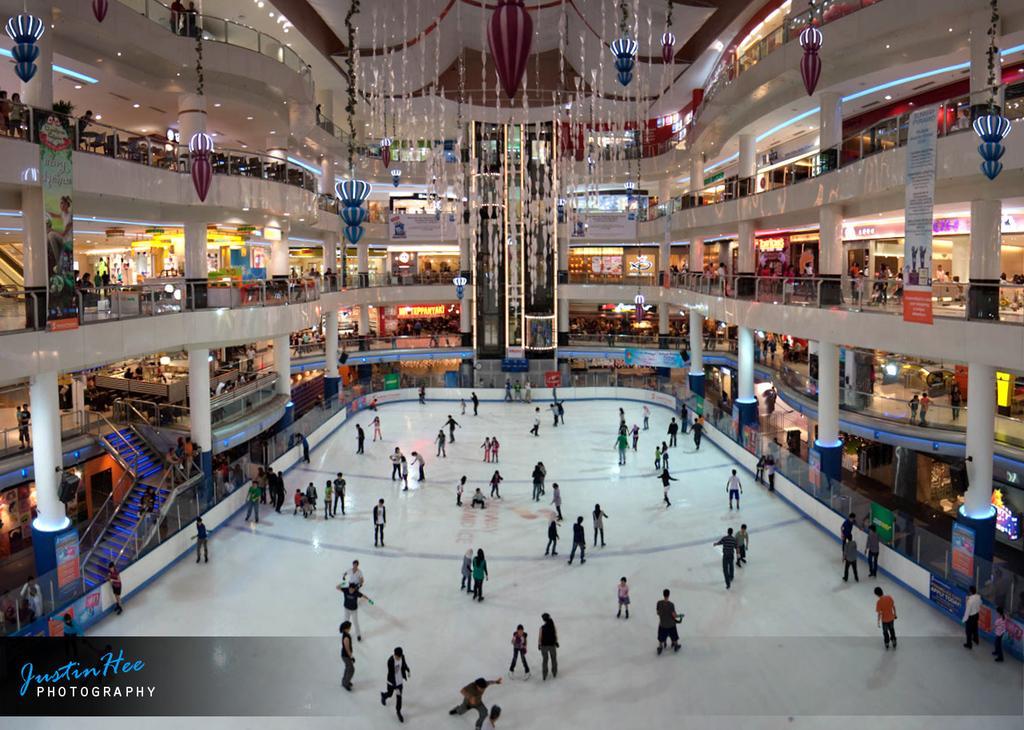In one or two sentences, can you explain what this image depicts? In this image, there are a few people. We can see the ground. We can see some stores, pillars and boards with text. We can also see the fence. We can see some stairs and the railing. We can see some glass and objects hanging. We can also see some text on the bottom left corner. 